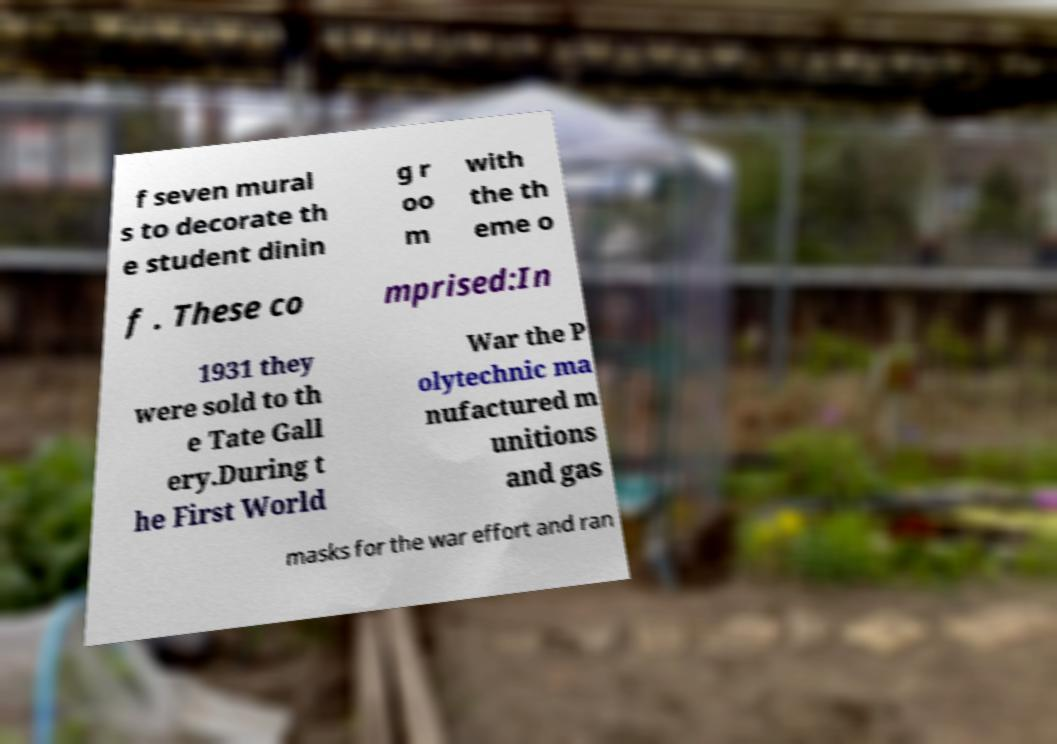Could you assist in decoding the text presented in this image and type it out clearly? f seven mural s to decorate th e student dinin g r oo m with the th eme o f . These co mprised:In 1931 they were sold to th e Tate Gall ery.During t he First World War the P olytechnic ma nufactured m unitions and gas masks for the war effort and ran 